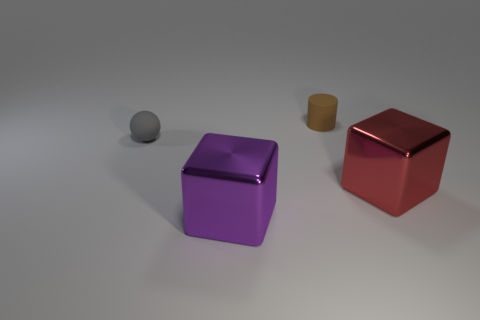Can you describe the lighting and atmosphere in the image? The lighting in the image is soft and diffused, with shadows indicating a light source coming from the upper right. The atmosphere is serene and calm, with a neutral background that doesn't detract from the objects. 